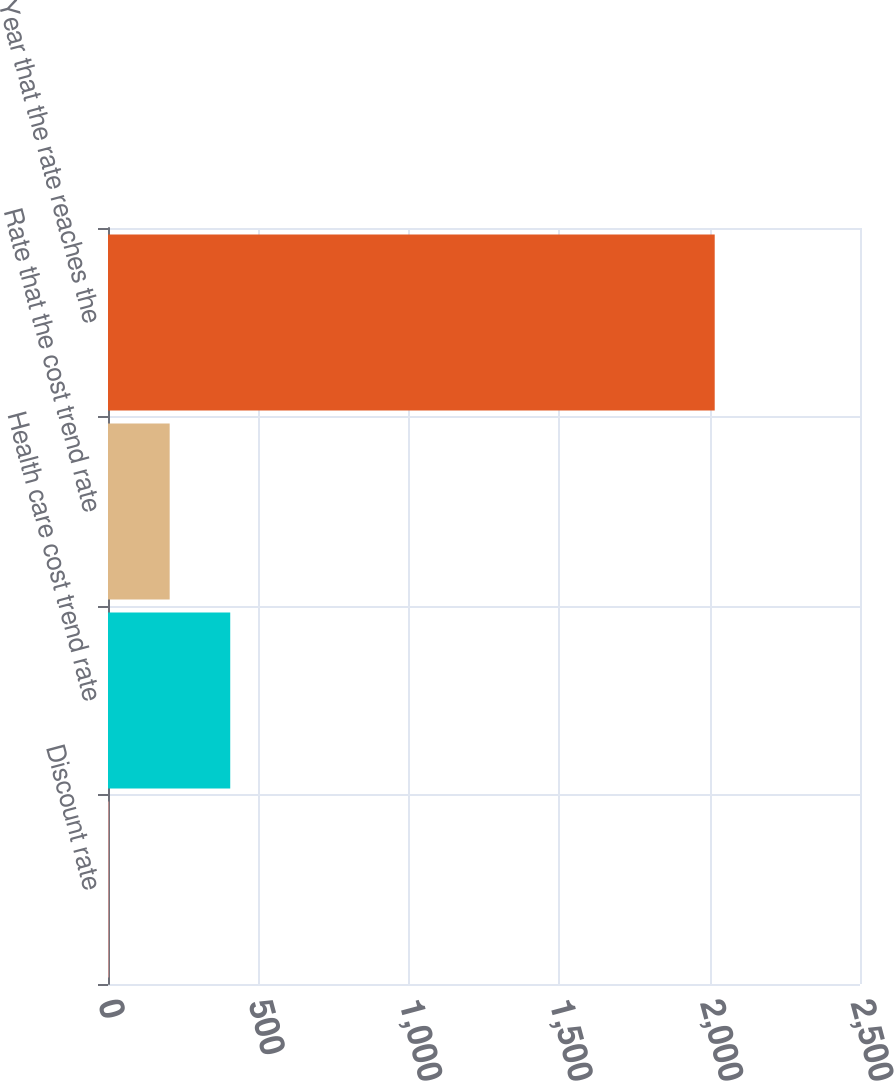Convert chart to OTSL. <chart><loc_0><loc_0><loc_500><loc_500><bar_chart><fcel>Discount rate<fcel>Health care cost trend rate<fcel>Rate that the cost trend rate<fcel>Year that the rate reaches the<nl><fcel>3.7<fcel>406.36<fcel>205.03<fcel>2017<nl></chart> 